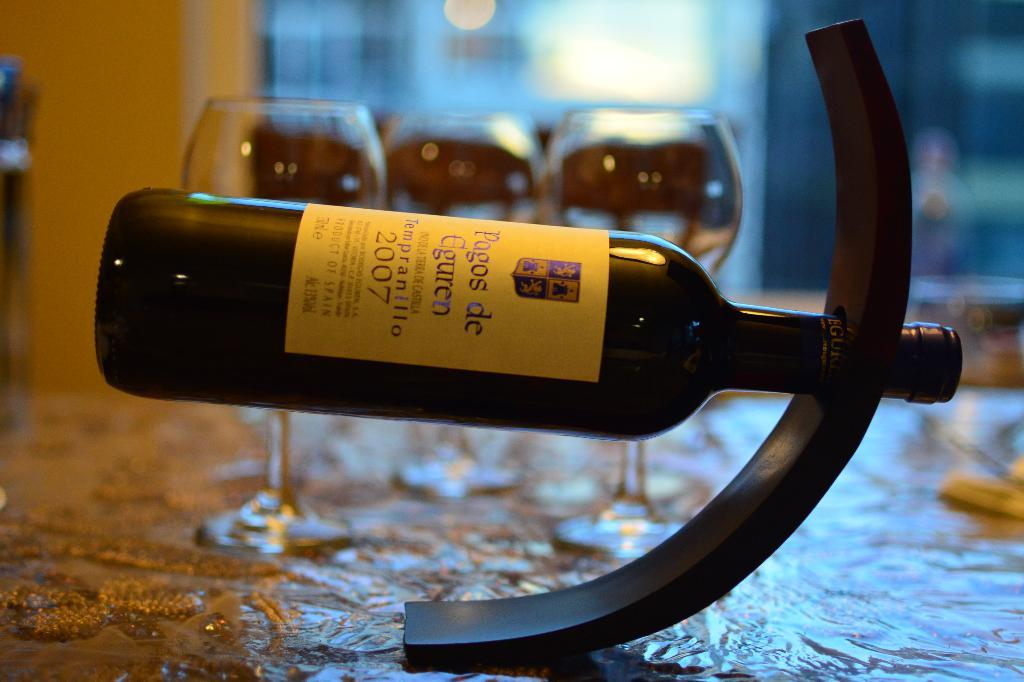<image>
Summarize the visual content of the image. A bottle is labeled with the year 2007 and is tipped to the side. 